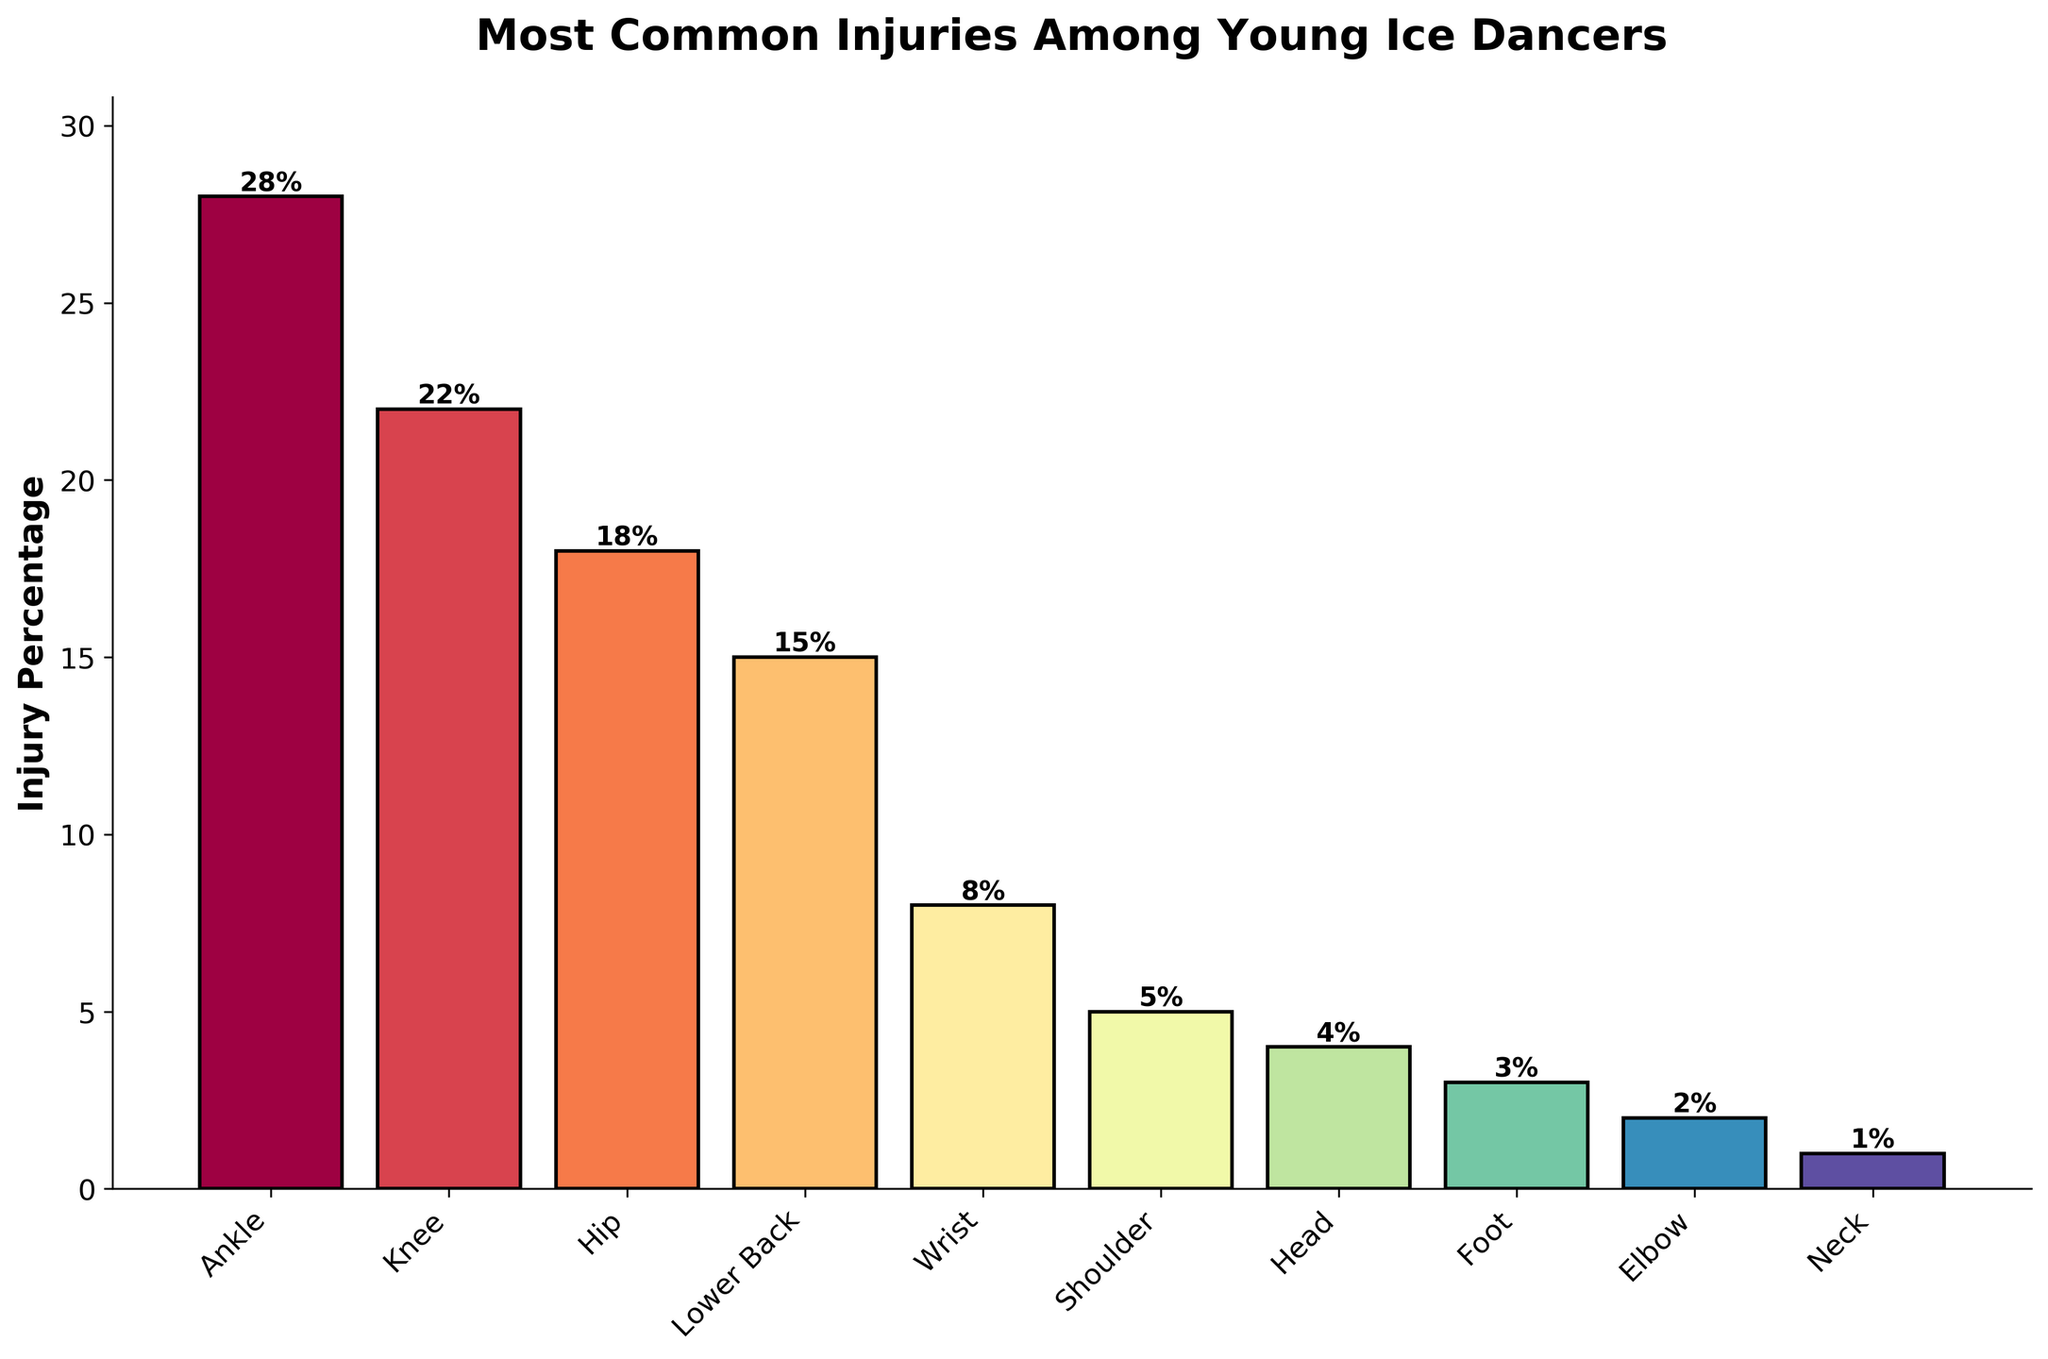What body part has the highest injury percentage among young ice dancers? The bar chart shows that the "Ankle" has the highest bar, indicating the largest injury percentage among the listed body parts.
Answer: Ankle Which two body parts have the most similar injury percentages? Looking at the bar heights, the injury percentages for "Knee" and "Hip" are close to each other, with the Knee at 22% and the Hip at 18%.
Answer: Knee and Hip What is the combined injury percentage for the Ankle, Knee, and Hip? Summing the percentages for Ankle (28%), Knee (22%), and Hip (18%) gives us 28 + 22 + 18.
Answer: 68% How many body parts have an injury percentage of 5% or less? The body parts with an injury percentage of 5% or less are: Shoulder (5%), Head (4%), Foot (3%), Elbow (2%), and Neck (1%). Counting these gives us 5 body parts.
Answer: 5 Is the Neck's injury percentage greater than, less than, or equal to the Elbow's injury percentage? By comparing the bar heights, it is evident that the Neck’s injury percentage (1%) is less than the Elbow’s injury percentage (2%).
Answer: Less than Which body part has a higher injury percentage, the Lower Back or the Wrist? Comparing the bar heights, the Lower Back has a higher injury percentage (15%) than the Wrist (8%).
Answer: Lower Back What is the difference in injury percentage between the Shoulder and the Foot? The injury percentage for the Shoulder is 5% and for the Foot is 3%. The difference is calculated as 5% - 3%.
Answer: 2% What percentage does the top three body parts (Ankle, Knee, Hip) represent out of the total listed injuries? First, calculate the total percentage by summing all the percentages (28 + 22 + 18 + 15 + 8 + 5 + 4 + 3 + 2 + 1 = 106). Then sum the top three (28 + 22 + 18 = 68) and find the proportion (68/106).
Answer: 64.2% If a young ice dancer has a combined injury percentage of 50%, which combination(s) of body parts could this represent? Reviewing combinations of percentages, possible combinations include: Ankle (28%) + Knee (22%), Ankle (28%) + Hip (18%) + other combinations potentially equal to 50 but these are the simplest and closest significant ones.
Answer: Ankle and Knee or Ankle and Hip 